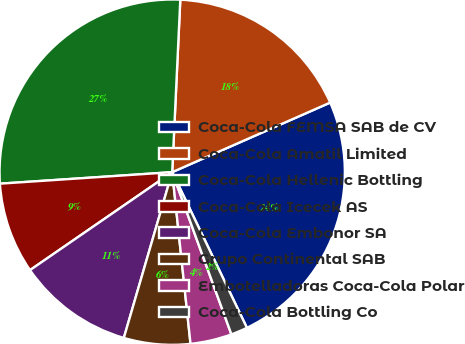<chart> <loc_0><loc_0><loc_500><loc_500><pie_chart><fcel>Coca-Cola FEMSA SAB de CV<fcel>Coca-Cola Amatil Limited<fcel>Coca-Cola Hellenic Bottling<fcel>Coca-Cola Icecek AS<fcel>Coca-Cola Embonor SA<fcel>Grupo Continental SAB<fcel>Embotelladoras Coca-Cola Polar<fcel>Coca-Cola Bottling Co<nl><fcel>24.48%<fcel>17.65%<fcel>26.81%<fcel>8.54%<fcel>10.88%<fcel>6.21%<fcel>3.88%<fcel>1.55%<nl></chart> 